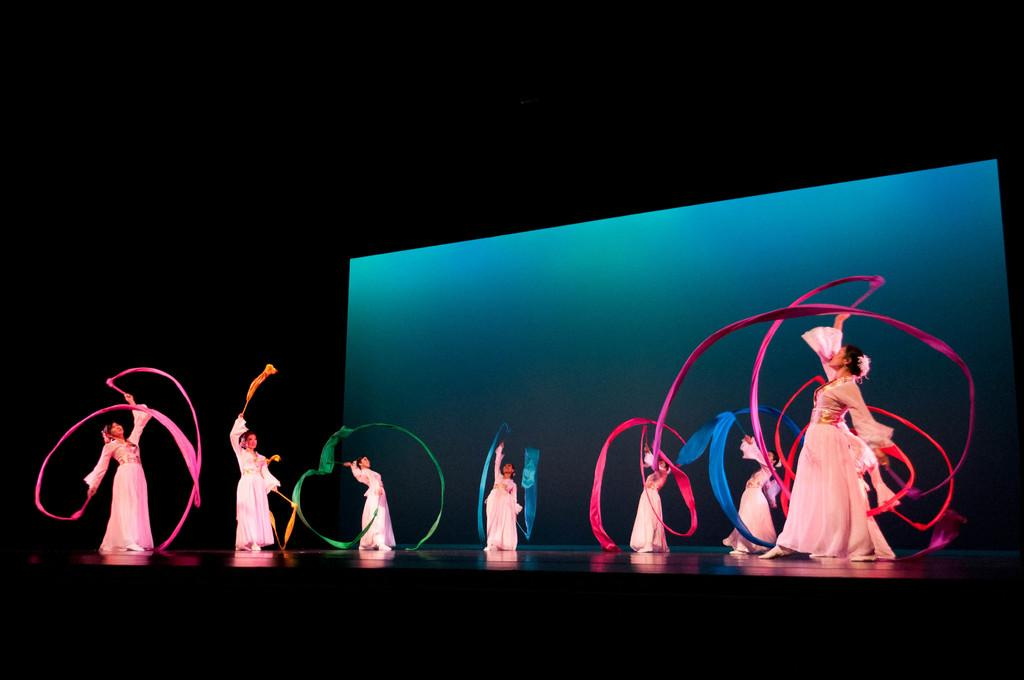What is happening in the image? There is a group of women performing on a dais in the image. Can you describe the setting of the performance? The women are performing on a dais, and there is a screen in the background of the image. What type of hill can be seen in the background of the image? There is no hill present in the background of the image; it features a screen instead. Can you tell me how many wristwatches are visible on the women's wrists in the image? There is no information about wristwatches or the women's wrists in the image. 